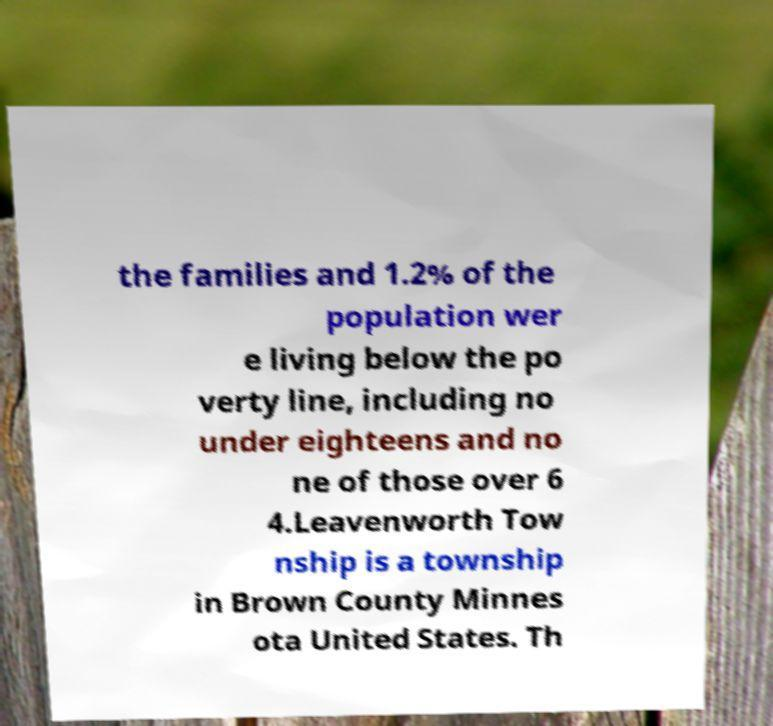Please identify and transcribe the text found in this image. the families and 1.2% of the population wer e living below the po verty line, including no under eighteens and no ne of those over 6 4.Leavenworth Tow nship is a township in Brown County Minnes ota United States. Th 